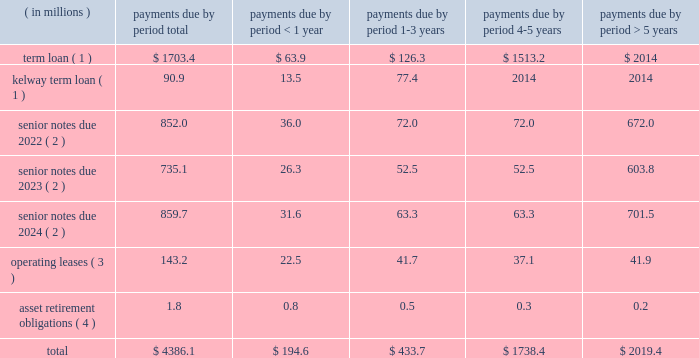Table of contents ended december 31 , 2015 and 2014 , respectively .
The increase in cash provided by accounts payable-inventory financing was primarily due to a new vendor added to our previously existing inventory financing agreement .
For a description of the inventory financing transactions impacting each period , see note 6 ( inventory financing agreements ) to the accompanying consolidated financial statements .
For a description of the debt transactions impacting each period , see note 8 ( long-term debt ) to the accompanying consolidated financial statements .
Net cash used in financing activities decreased $ 56.3 million in 2014 compared to 2013 .
The decrease was primarily driven by several debt refinancing transactions during each period and our july 2013 ipo , which generated net proceeds of $ 424.7 million after deducting underwriting discounts , expenses and transaction costs .
The net impact of our debt transactions resulted in cash outflows of $ 145.9 million and $ 518.3 million during 2014 and 2013 , respectively , as cash was used in each period to reduce our total long-term debt .
For a description of the debt transactions impacting each period , see note 8 ( long-term debt ) to the accompanying consolidated financial statements .
Long-term debt and financing arrangements as of december 31 , 2015 , we had total indebtedness of $ 3.3 billion , of which $ 1.6 billion was secured indebtedness .
At december 31 , 2015 , we were in compliance with the covenants under our various credit agreements and indentures .
The amount of cdw 2019s restricted payment capacity under the senior secured term loan facility was $ 679.7 million at december 31 , 2015 .
For further details regarding our debt and each of the transactions described below , see note 8 ( long-term debt ) to the accompanying consolidated financial statements .
During the year ended december 31 , 2015 , the following events occurred with respect to our debt structure : 2022 on august 1 , 2015 , we consolidated kelway 2019s term loan and kelway 2019s revolving credit facility .
Kelway 2019s term loan is denominated in british pounds .
The kelway revolving credit facility is a multi-currency revolving credit facility under which kelway is permitted to borrow an aggregate amount of a350.0 million ( $ 73.7 million ) as of december 31 , 2015 .
2022 on march 3 , 2015 , we completed the issuance of $ 525.0 million principal amount of 5.0% ( 5.0 % ) senior notes due 2023 which will mature on september 1 , 2023 .
2022 on march 3 , 2015 , we redeemed the remaining $ 503.9 million aggregate principal amount of the 8.5% ( 8.5 % ) senior notes due 2019 , plus accrued and unpaid interest through the date of redemption , april 2 , 2015 .
Inventory financing agreements we have entered into agreements with certain financial intermediaries to facilitate the purchase of inventory from various suppliers under certain terms and conditions .
These amounts are classified separately as accounts payable-inventory financing on the consolidated balance sheets .
We do not incur any interest expense associated with these agreements as balances are paid when they are due .
For further details , see note 6 ( inventory financing agreements ) to the accompanying consolidated financial statements .
Contractual obligations we have future obligations under various contracts relating to debt and interest payments , operating leases and asset retirement obligations .
Our estimated future payments , based on undiscounted amounts , under contractual obligations that existed as of december 31 , 2015 , are as follows: .

What was the difference in principal amount of senior notes due 2022 compared to senior notes due 2023 , in millions? 
Computations: (852.0 - 735.1)
Answer: 116.9. 